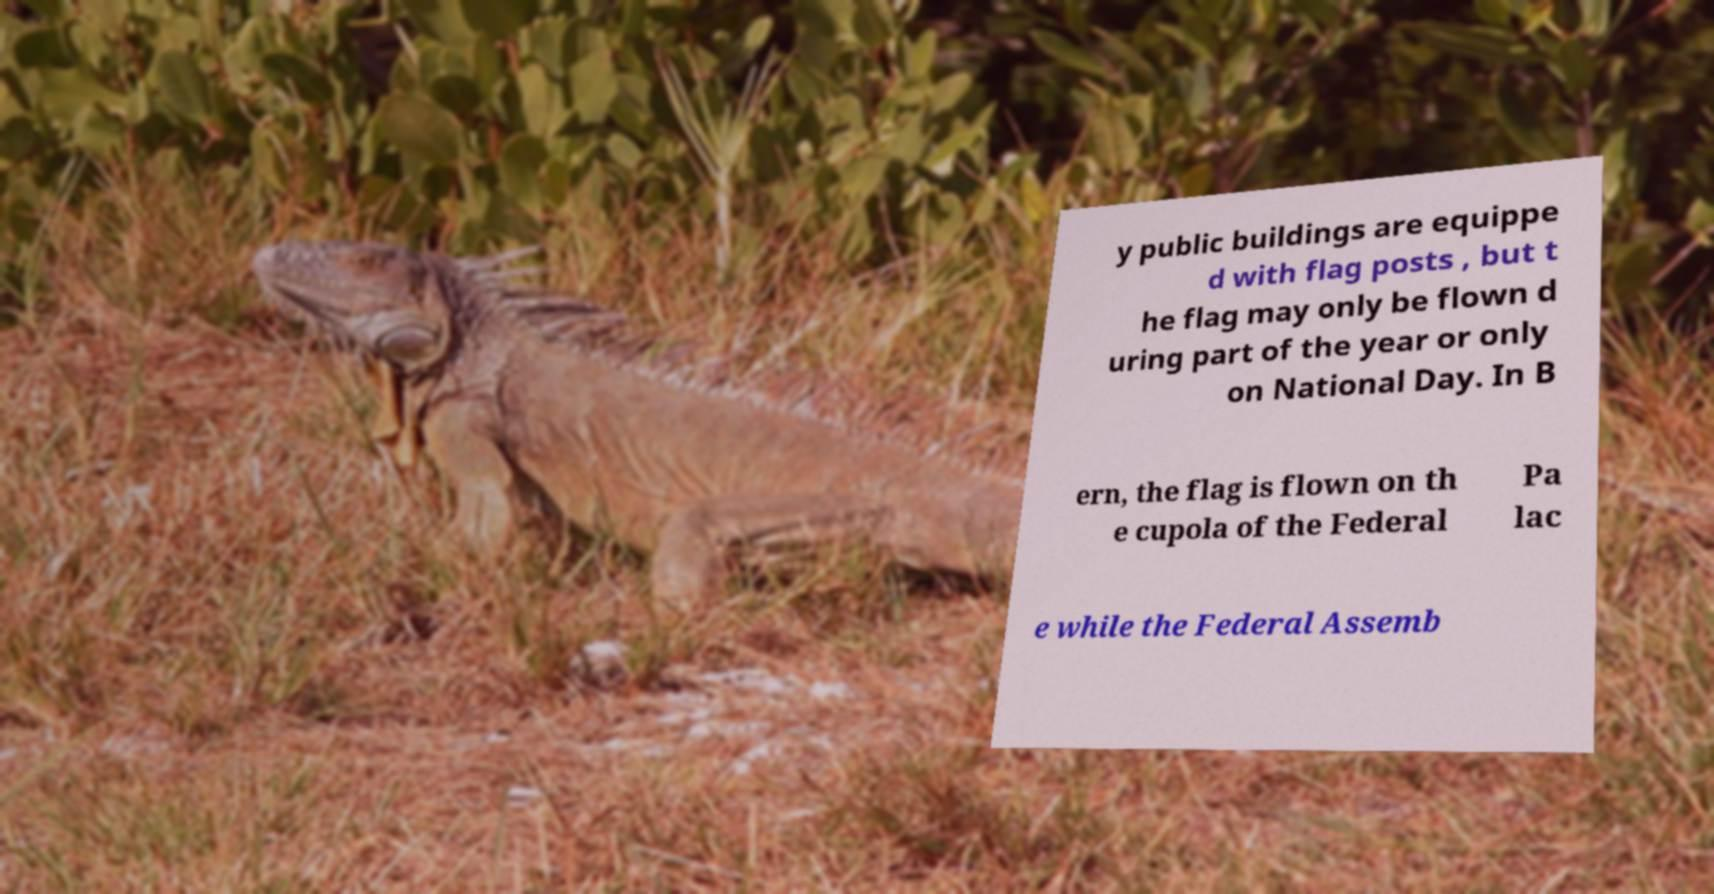Could you assist in decoding the text presented in this image and type it out clearly? y public buildings are equippe d with flag posts , but t he flag may only be flown d uring part of the year or only on National Day. In B ern, the flag is flown on th e cupola of the Federal Pa lac e while the Federal Assemb 